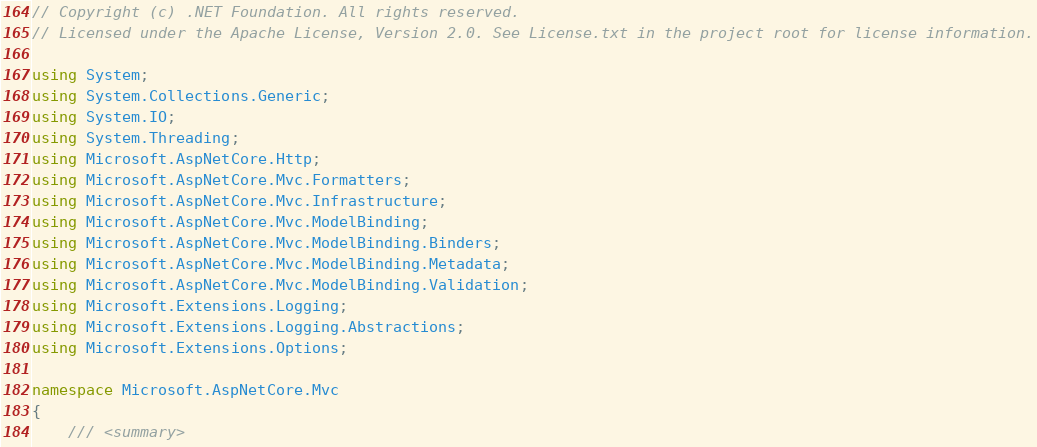<code> <loc_0><loc_0><loc_500><loc_500><_C#_>// Copyright (c) .NET Foundation. All rights reserved.
// Licensed under the Apache License, Version 2.0. See License.txt in the project root for license information.

using System;
using System.Collections.Generic;
using System.IO;
using System.Threading;
using Microsoft.AspNetCore.Http;
using Microsoft.AspNetCore.Mvc.Formatters;
using Microsoft.AspNetCore.Mvc.Infrastructure;
using Microsoft.AspNetCore.Mvc.ModelBinding;
using Microsoft.AspNetCore.Mvc.ModelBinding.Binders;
using Microsoft.AspNetCore.Mvc.ModelBinding.Metadata;
using Microsoft.AspNetCore.Mvc.ModelBinding.Validation;
using Microsoft.Extensions.Logging;
using Microsoft.Extensions.Logging.Abstractions;
using Microsoft.Extensions.Options;

namespace Microsoft.AspNetCore.Mvc
{
    /// <summary></code> 